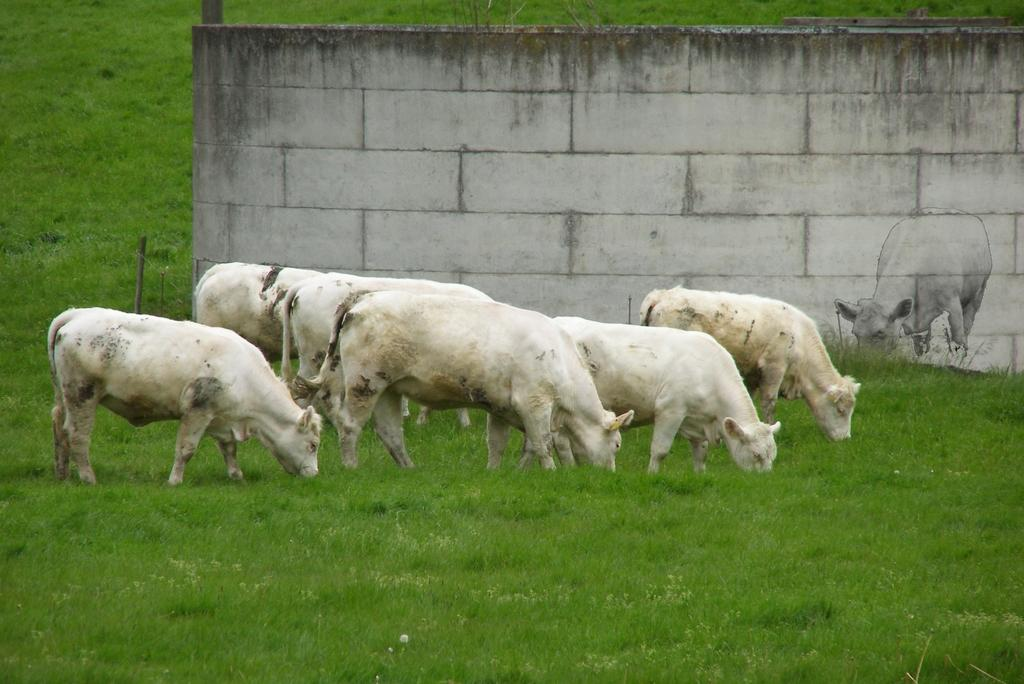What animals are present in the image? There are cows in the image. What are the cows doing in the image? The cows are eating grass. What can be seen in the background of the image? There is a wall in the background of the image. Is there any artwork visible in the image? Yes, there is an art of a cow on the wall. How many balloons are tied to the cows in the image? There are no balloons present in the image; the cows are eating grass and there is an art of a cow on the wall. 